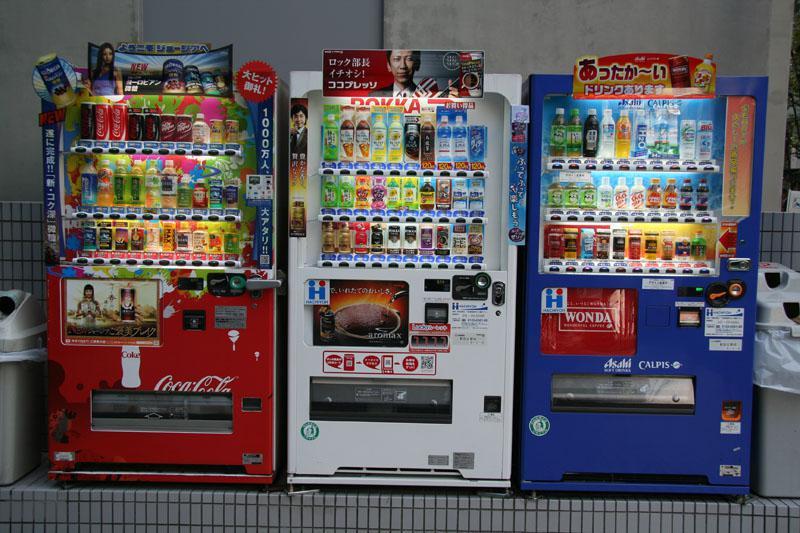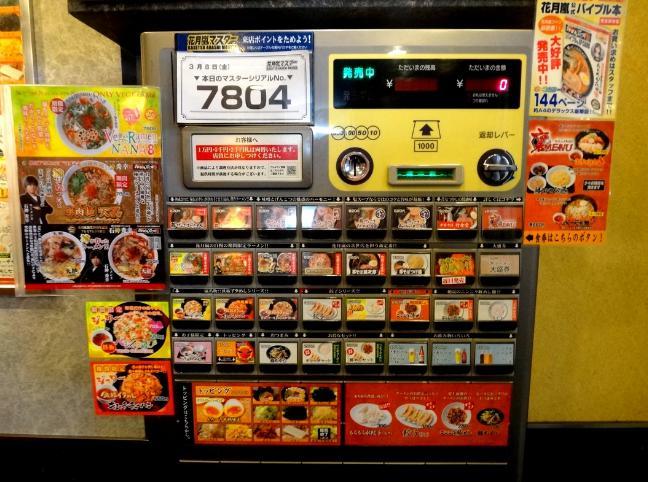The first image is the image on the left, the second image is the image on the right. Analyze the images presented: Is the assertion "A bank of exactly three vending machines appears in one image." valid? Answer yes or no. Yes. The first image is the image on the left, the second image is the image on the right. For the images shown, is this caption "An image shows a row of exactly three vending machines." true? Answer yes or no. Yes. 